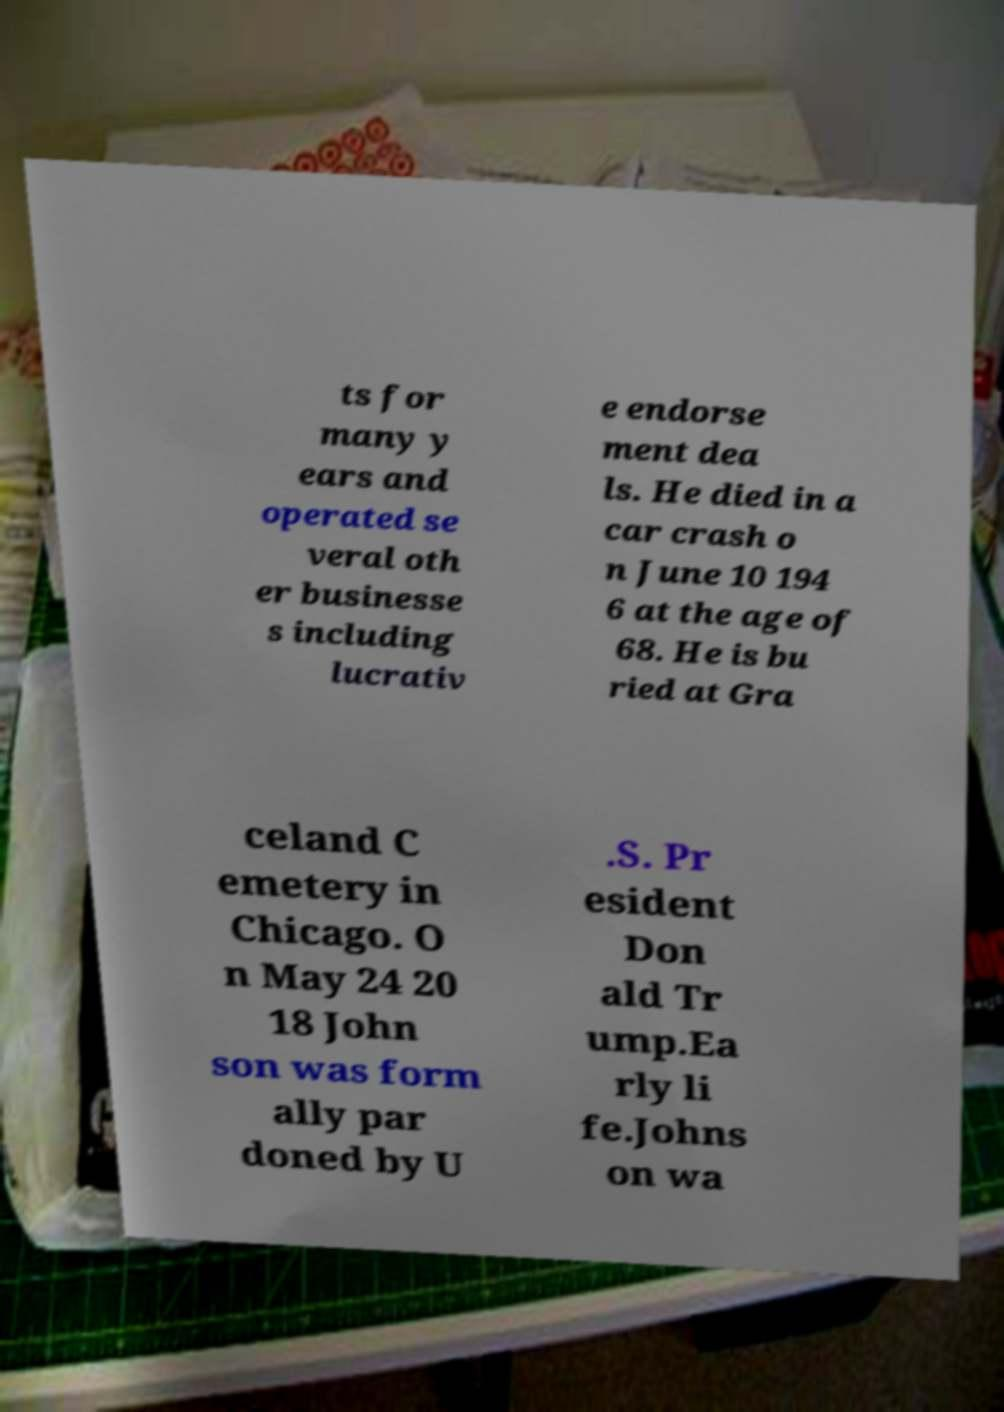Please read and relay the text visible in this image. What does it say? ts for many y ears and operated se veral oth er businesse s including lucrativ e endorse ment dea ls. He died in a car crash o n June 10 194 6 at the age of 68. He is bu ried at Gra celand C emetery in Chicago. O n May 24 20 18 John son was form ally par doned by U .S. Pr esident Don ald Tr ump.Ea rly li fe.Johns on wa 